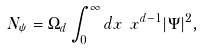<formula> <loc_0><loc_0><loc_500><loc_500>N _ { \psi } = \Omega _ { d } \int _ { 0 } ^ { \infty } d x \ x ^ { d - 1 } | \Psi | ^ { 2 } ,</formula> 